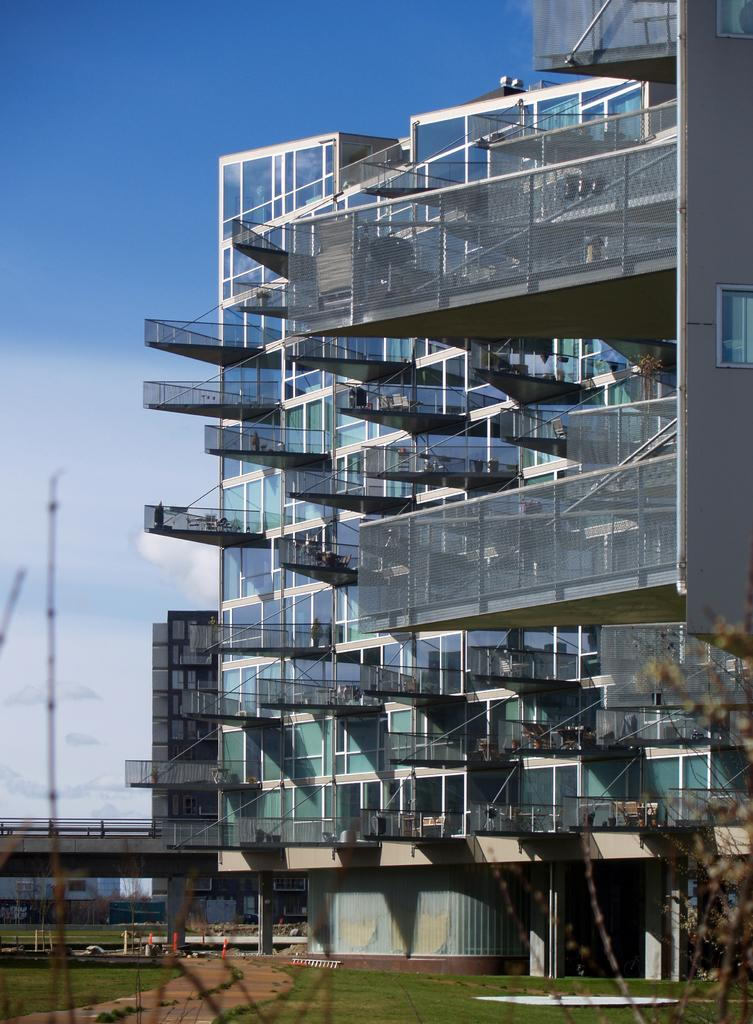What structure is present in the image? There is a building in the image. What objects are on the building? There are glasses on the building. What type of vegetation is visible in the image? There is grass visible in the image. What type of suit is the judge wearing in the image? There is no judge or suit present in the image. How is the wax being used in the image? There is no wax present in the image. 